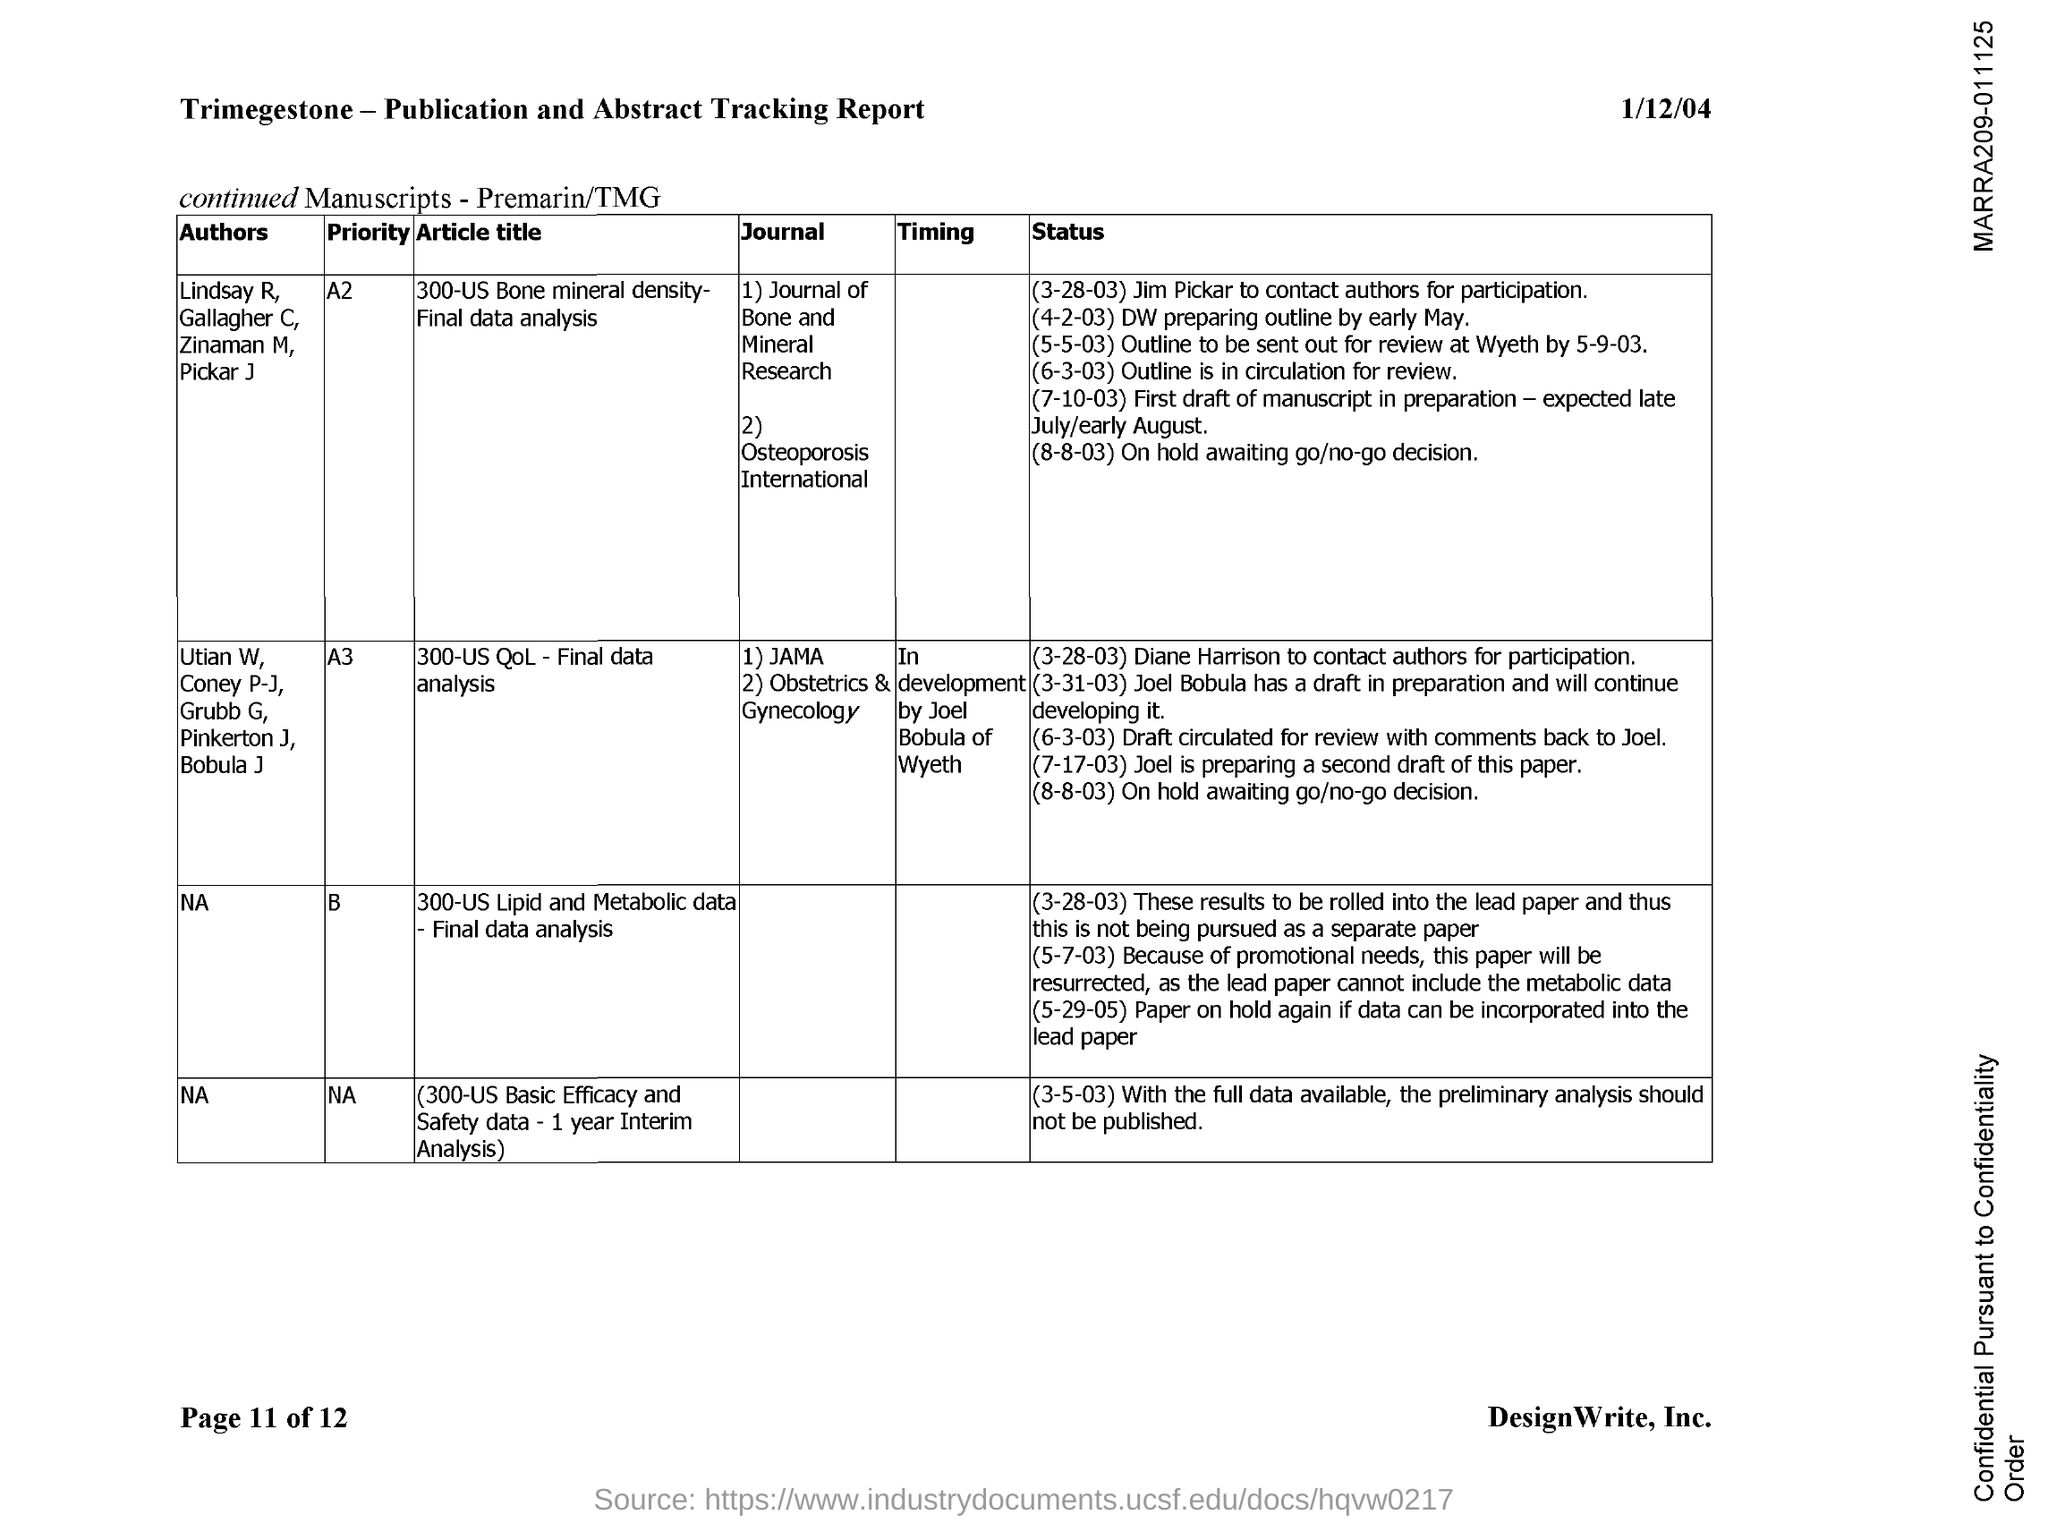Who are the authors of the article titled '300-US Bone mineral density- Final data analysis'?
Your answer should be very brief. Lindsay R, Gallagher C, Zinaman  M, Pickar J. Who are the authors of the article titled ''300-US QoL - Final data analysis '?
Keep it short and to the point. Utian W, Coney P-J, Grubb G, Pinkerton J, Bobula J. What is the page no mentioned in this document?
Provide a short and direct response. Page 11. What is the date mentioned in the header of the document?
Your answer should be very brief. 1/12/04. 